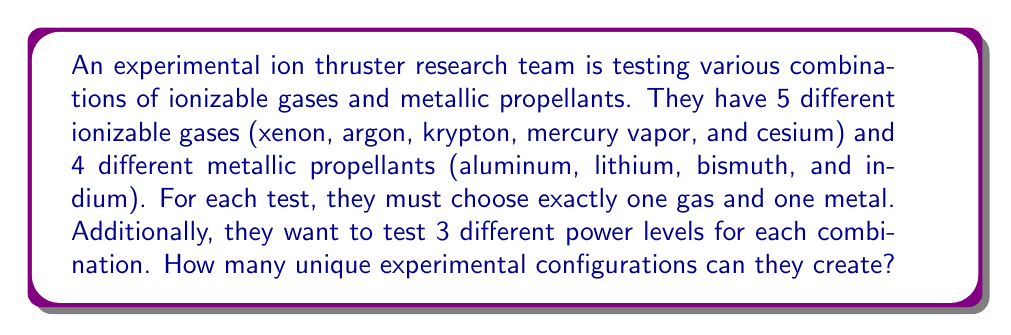Help me with this question. Let's break this problem down step-by-step:

1) First, we need to determine how many ways we can choose the gas and metal combination:
   - There are 5 choices for the ionizable gas
   - There are 4 choices for the metallic propellant
   - For each test, we must choose one of each

   This is a multiplication principle problem. We multiply the number of choices for each independent decision:

   $$ 5 \times 4 = 20 $$

   So there are 20 possible gas-metal combinations.

2) Now, for each of these 20 combinations, we need to consider the 3 different power levels:
   - Each gas-metal combination will be tested at 3 different power levels

   This means we need to multiply our previous result by 3:

   $$ 20 \times 3 = 60 $$

3) Therefore, the total number of unique experimental configurations is 60.

This problem can be viewed as a combination with repetition, where we're selecting one item from each of three categories (gases, metals, power levels) and the order doesn't matter within each category. The formula for this is:

$$ \text{Total Combinations} = n_1 \times n_2 \times n_3 $$

Where $n_1$, $n_2$, and $n_3$ are the number of choices in each category.

In this case:
$$ \text{Total Combinations} = 5 \times 4 \times 3 = 60 $$
Answer: 60 unique experimental configurations 